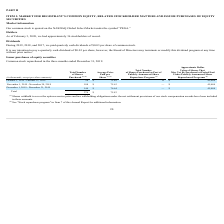From Pegasystems's financial document, What are the respective number of shares purchased in October and November 2019? The document shows two values: 24 and 108 (in thousands). From the document: "November 1, 2019 - November 30, 2019 108 $ 75.63 — $ 45,484 October 1, 2019 - October 31, 2019 24 $ 71.89 12 $ 45,484..." Also, What are the respective number of shares purchased in November and December 2019? The document shows two values: 108 and 144 (in thousands). From the document: "December 1, 2019 - December 31, 2019 144 $ 76.64 — $ 45,484 November 1, 2019 - November 30, 2019 108 $ 75.63 — $ 45,484..." Also, What is the total number of shares purchased in the three months ended December 31, 2019? According to the financial document, 276 (in thousands). The relevant text states: "Total 276 $ 75.83..." Also, can you calculate: What is the average number of shares purchased in the three months ended December 31, 2019? To answer this question, I need to perform calculations using the financial data. The calculation is: (24 + 108 + 144)/3 , which equals 92 (in thousands). This is based on the information: "December 1, 2019 - December 31, 2019 144 $ 76.64 — $ 45,484 November 1, 2019 - November 30, 2019 108 $ 75.63 — $ 45,484 October 1, 2019 - October 31, 2019 24 $ 71.89 12 $ 45,484..." The key data points involved are: 108, 144, 24. Also, can you calculate: What percentage of the total shares purchased in the last three months of 2019 are bought in November? Based on the calculation: 108/276 , the result is 39.13 (percentage). This is based on the information: "November 1, 2019 - November 30, 2019 108 $ 75.63 — $ 45,484 Total 276 $ 75.83..." The key data points involved are: 108, 276. Also, can you calculate: What is the difference in the number of shares bought between October and November? Based on the calculation: 108-24 , the result is 84 (in thousands). This is based on the information: "November 1, 2019 - November 30, 2019 108 $ 75.63 — $ 45,484 October 1, 2019 - October 31, 2019 24 $ 71.89 12 $ 45,484..." The key data points involved are: 108, 24. 